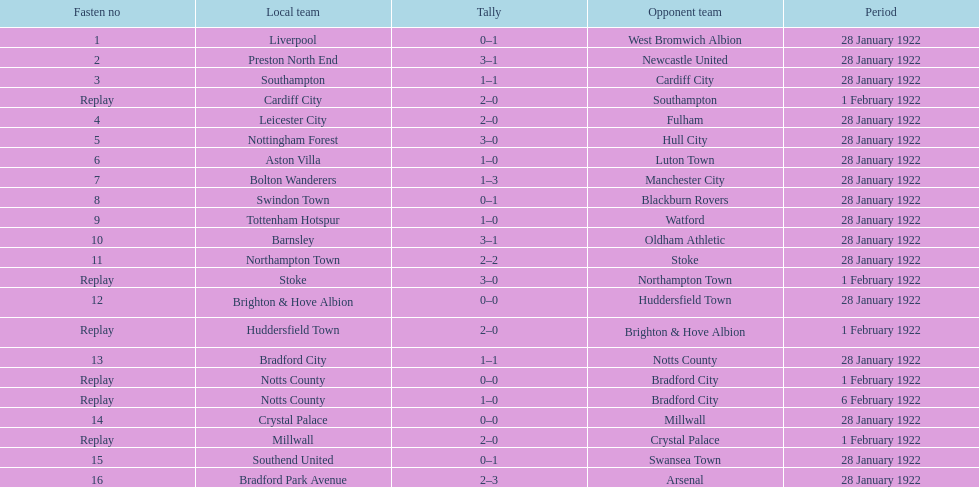What is the number of points scored on 6 february 1922? 1. 